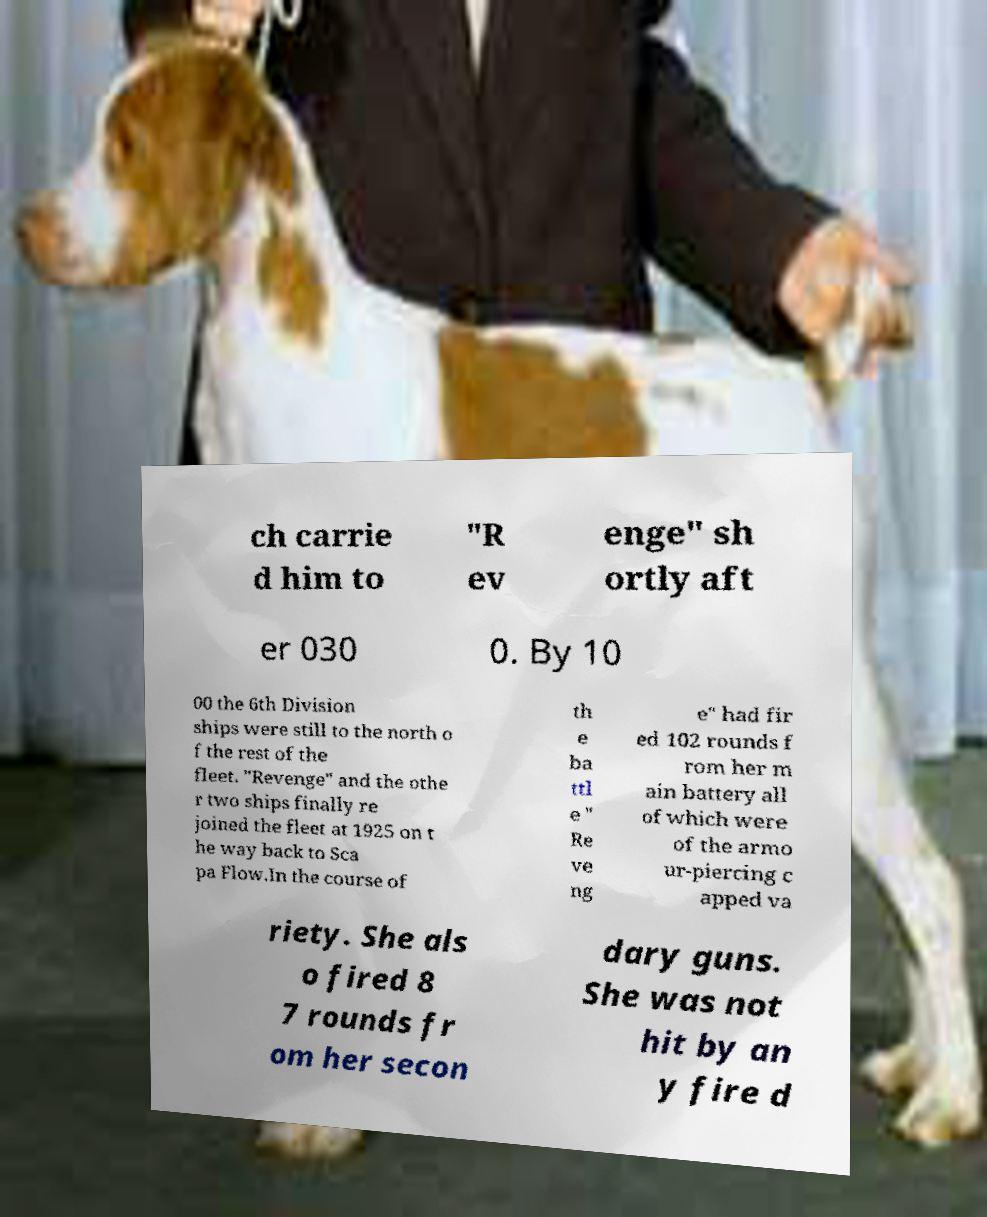I need the written content from this picture converted into text. Can you do that? ch carrie d him to "R ev enge" sh ortly aft er 030 0. By 10 00 the 6th Division ships were still to the north o f the rest of the fleet. "Revenge" and the othe r two ships finally re joined the fleet at 1925 on t he way back to Sca pa Flow.In the course of th e ba ttl e " Re ve ng e" had fir ed 102 rounds f rom her m ain battery all of which were of the armo ur-piercing c apped va riety. She als o fired 8 7 rounds fr om her secon dary guns. She was not hit by an y fire d 